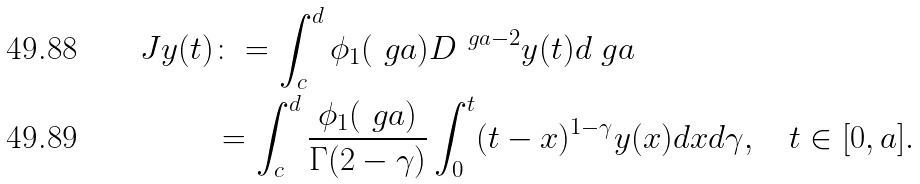<formula> <loc_0><loc_0><loc_500><loc_500>J y ( t ) & \colon = \int _ { c } ^ { d } \phi _ { 1 } ( \ g a ) D ^ { \ g a - 2 } y ( t ) d \ g a \\ & = \int _ { c } ^ { d } \frac { \phi _ { 1 } ( \ g a ) } { \Gamma ( 2 - \gamma ) } \int _ { 0 } ^ { t } ( t - x ) ^ { 1 - \gamma } y ( x ) d x d \gamma , \quad t \in [ 0 , a ] .</formula> 